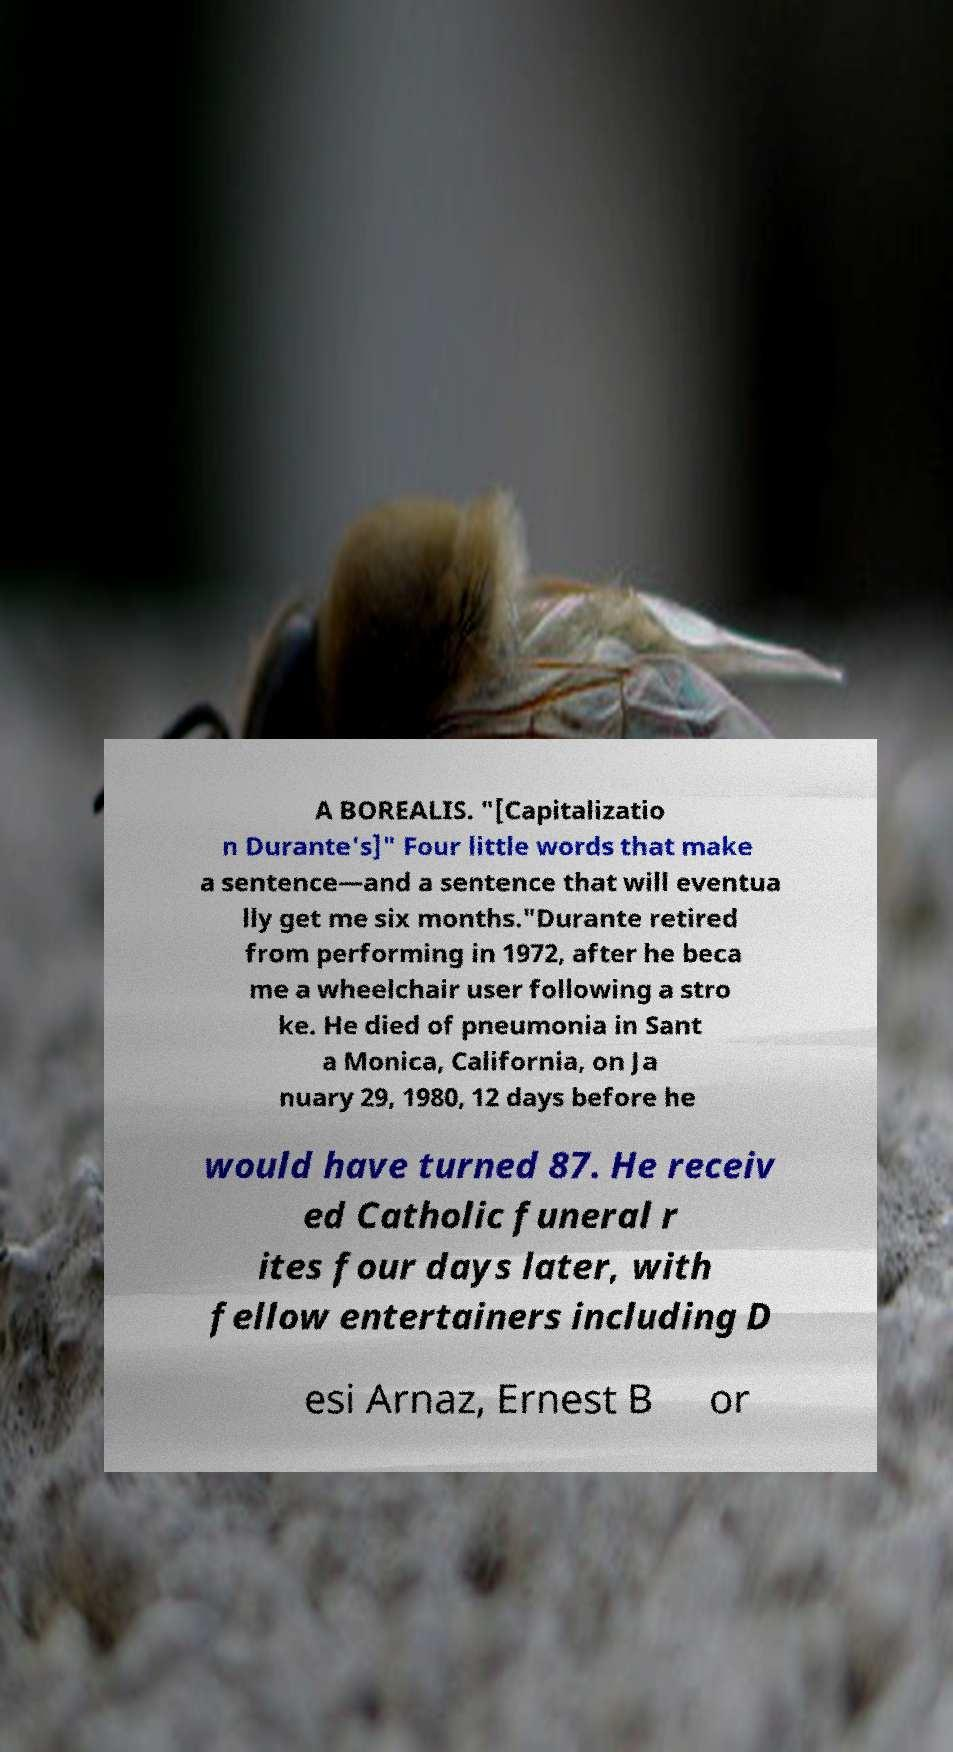Please read and relay the text visible in this image. What does it say? A BOREALIS. "[Capitalizatio n Durante's]" Four little words that make a sentence—and a sentence that will eventua lly get me six months."Durante retired from performing in 1972, after he beca me a wheelchair user following a stro ke. He died of pneumonia in Sant a Monica, California, on Ja nuary 29, 1980, 12 days before he would have turned 87. He receiv ed Catholic funeral r ites four days later, with fellow entertainers including D esi Arnaz, Ernest B or 